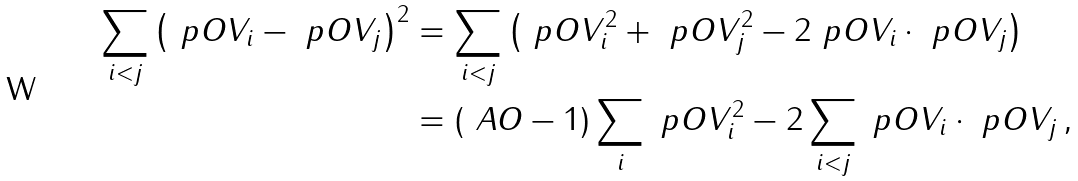Convert formula to latex. <formula><loc_0><loc_0><loc_500><loc_500>\sum _ { i < j } \left ( \ p O V _ { i } - \ p O V _ { j } \right ) ^ { 2 } & = \sum _ { i < j } \left ( \ p O V _ { i } ^ { 2 } + \ p O V _ { j } ^ { 2 } - 2 \ p O V _ { i } \cdot \ p O V _ { j } \right ) \\ & = \left ( \ A O - 1 \right ) \sum _ { i } \ p O V _ { i } ^ { 2 } - 2 \sum _ { i < j } \ p O V _ { i } \cdot \ p O V _ { j } \, ,</formula> 